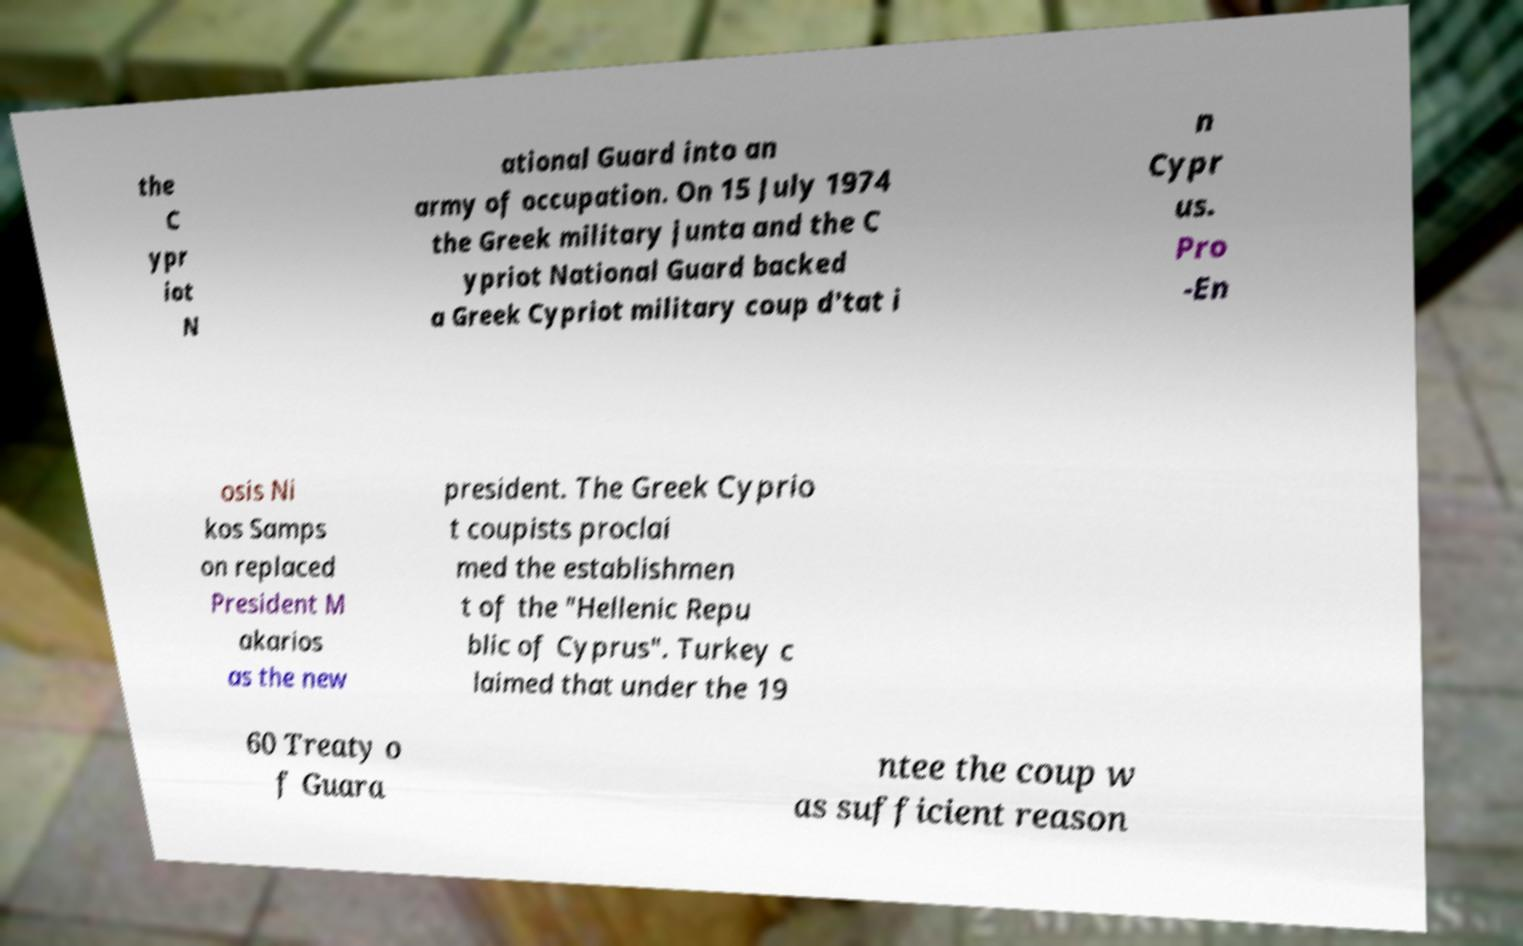I need the written content from this picture converted into text. Can you do that? the C ypr iot N ational Guard into an army of occupation. On 15 July 1974 the Greek military junta and the C ypriot National Guard backed a Greek Cypriot military coup d'tat i n Cypr us. Pro -En osis Ni kos Samps on replaced President M akarios as the new president. The Greek Cyprio t coupists proclai med the establishmen t of the "Hellenic Repu blic of Cyprus". Turkey c laimed that under the 19 60 Treaty o f Guara ntee the coup w as sufficient reason 